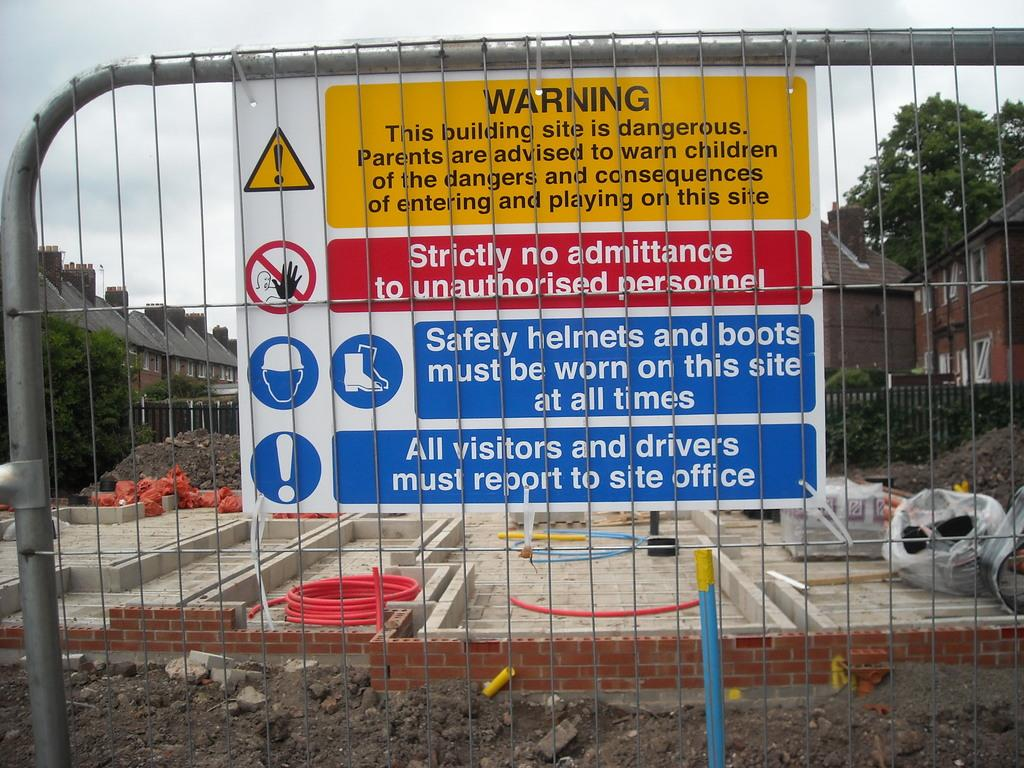<image>
Render a clear and concise summary of the photo. A construction site with warning signs and requiring safety boots and helmets 